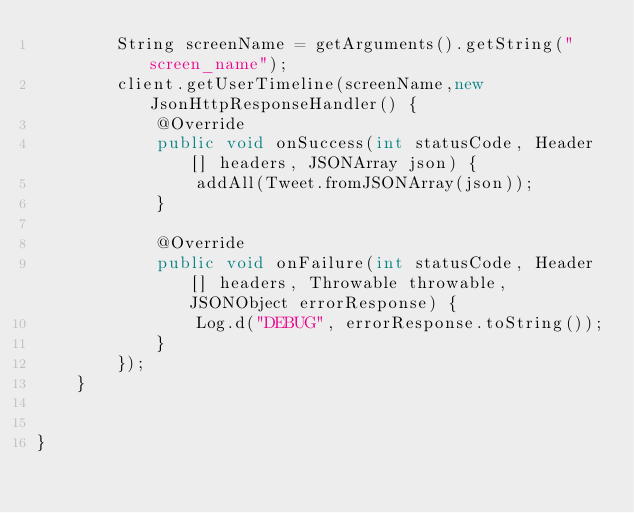Convert code to text. <code><loc_0><loc_0><loc_500><loc_500><_Java_>        String screenName = getArguments().getString("screen_name");
        client.getUserTimeline(screenName,new JsonHttpResponseHandler() {
            @Override
            public void onSuccess(int statusCode, Header[] headers, JSONArray json) {
                addAll(Tweet.fromJSONArray(json));
            }

            @Override
            public void onFailure(int statusCode, Header[] headers, Throwable throwable, JSONObject errorResponse) {
                Log.d("DEBUG", errorResponse.toString());
            }
        });
    }


}
</code> 